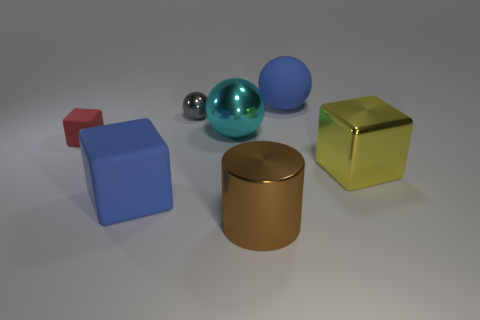Add 2 tiny gray shiny spheres. How many objects exist? 9 Subtract all blocks. How many objects are left? 4 Add 7 red cubes. How many red cubes exist? 8 Subtract 0 green balls. How many objects are left? 7 Subtract all tiny brown spheres. Subtract all blue spheres. How many objects are left? 6 Add 3 large yellow shiny things. How many large yellow shiny things are left? 4 